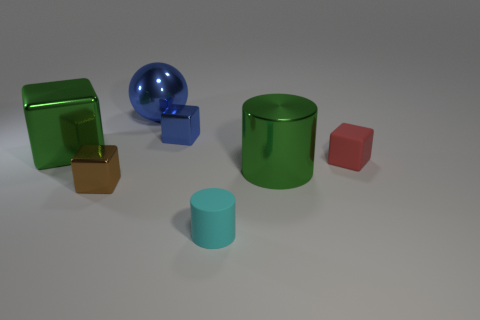Add 3 green metal blocks. How many objects exist? 10 Subtract all blocks. How many objects are left? 3 Subtract all big metallic blocks. Subtract all tiny blue shiny blocks. How many objects are left? 5 Add 4 spheres. How many spheres are left? 5 Add 5 brown matte cylinders. How many brown matte cylinders exist? 5 Subtract 0 yellow blocks. How many objects are left? 7 